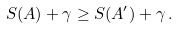<formula> <loc_0><loc_0><loc_500><loc_500>S ( A ) + \gamma \geq S ( A ^ { \prime } ) + \gamma \, .</formula> 